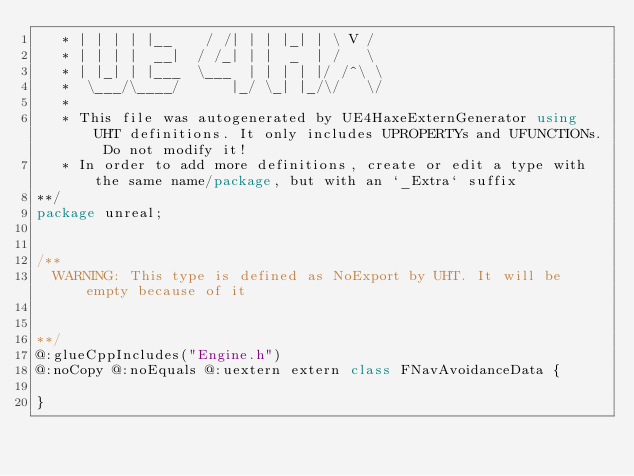Convert code to text. <code><loc_0><loc_0><loc_500><loc_500><_Haxe_>   * | | | | |__    / /| | | |_| | \ V /  
   * | | | |  __|  / /_| | |  _  | /   \  
   * | |_| | |___  \___  | | | | |/ /^\ \ 
   *  \___/\____/      |_/ \_| |_/\/   \/ 
   * 
   * This file was autogenerated by UE4HaxeExternGenerator using UHT definitions. It only includes UPROPERTYs and UFUNCTIONs. Do not modify it!
   * In order to add more definitions, create or edit a type with the same name/package, but with an `_Extra` suffix
**/
package unreal;


/**
  WARNING: This type is defined as NoExport by UHT. It will be empty because of it
  
  
**/
@:glueCppIncludes("Engine.h")
@:noCopy @:noEquals @:uextern extern class FNavAvoidanceData {
  
}
</code> 